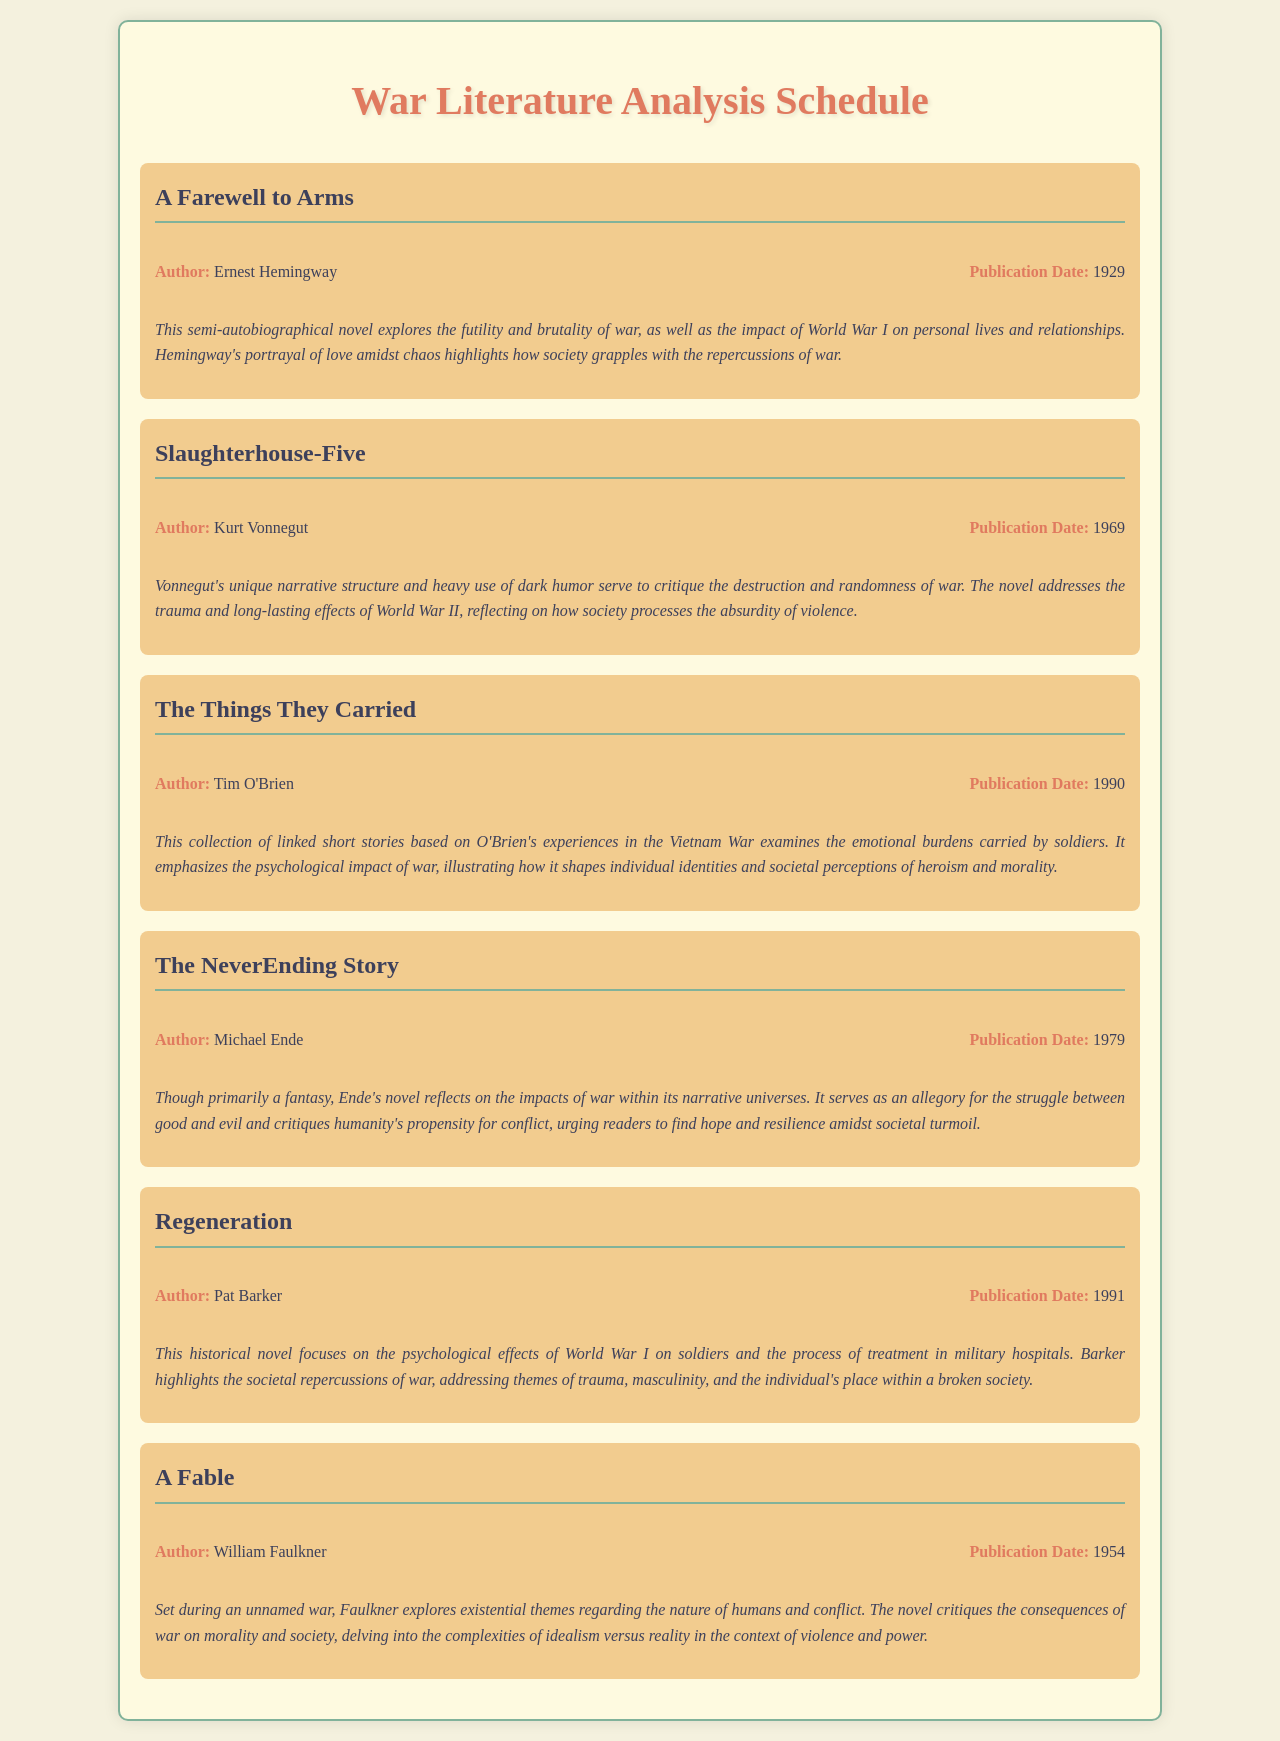What is the title of the first novel listed? The first novel listed in the document is "A Farewell to Arms."
Answer: A Farewell to Arms Who is the author of "Slaughterhouse-Five"? The document states that the author of "Slaughterhouse-Five" is Kurt Vonnegut.
Answer: Kurt Vonnegut In what year was "The Things They Carried" published? According to the document, "The Things They Carried" was published in 1990.
Answer: 1990 Which novel critiques the consequences of war on morality and society? "A Fable" by William Faulkner critiques the consequences of war on morality and society.
Answer: A Fable What is the thematic significance of "Regeneration"? The thematic significance of "Regeneration" focuses on psychological effects and societal repercussions of war.
Answer: Psychological effects and societal repercussions Which author wrote about the impact of World War I on personal lives? Ernest Hemingway wrote about the impact of World War I on personal lives in "A Farewell to Arms."
Answer: Ernest Hemingway What element is highlighted in Tim O'Brien's "The Things They Carried"? The document highlights the emotional burdens carried by soldiers in "The Things They Carried."
Answer: Emotional burdens What does Michael Ende's "The NeverEnding Story" serve as an allegory for? The document describes it as an allegory for the struggle between good and evil.
Answer: Struggle between good and evil 